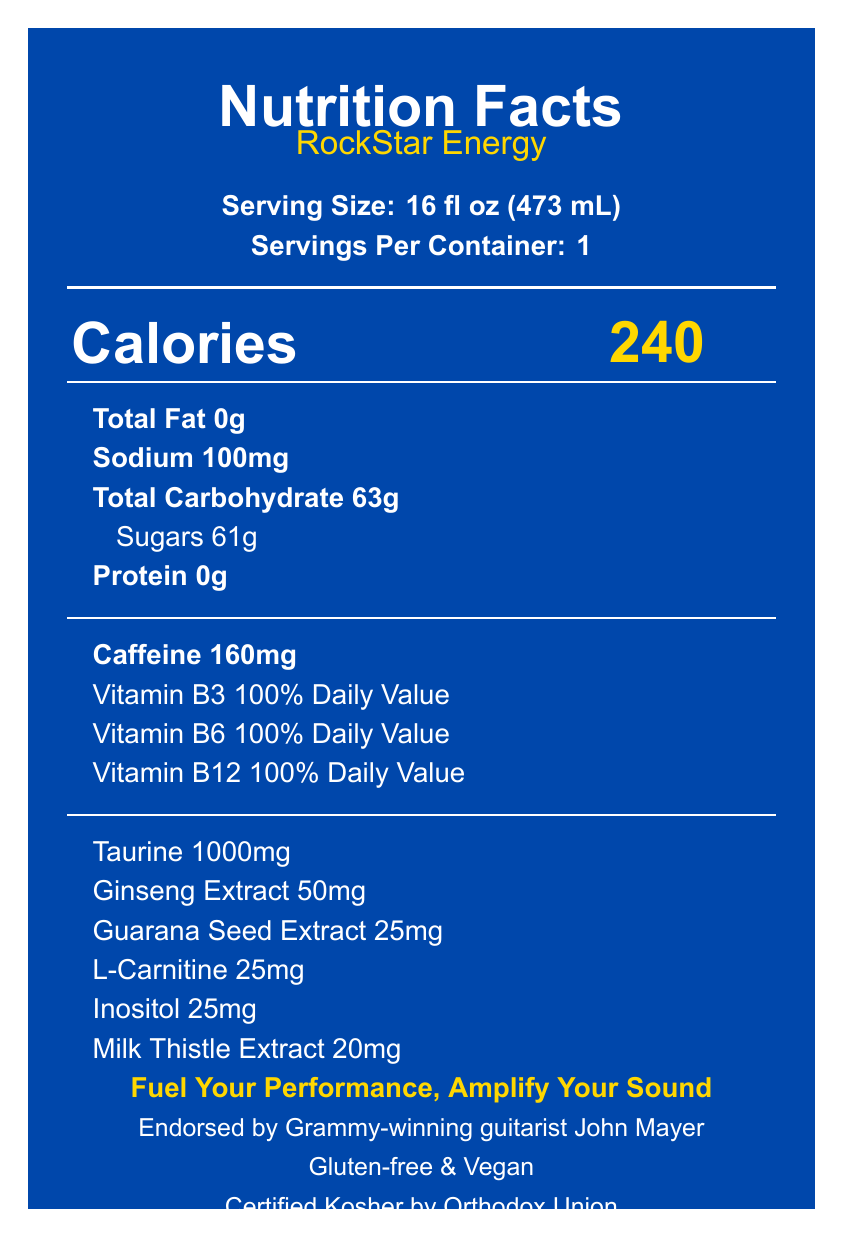what is the serving size for RockStar Energy? The serving size is clearly listed as 16 fl oz (473 mL) in the serving information section.
Answer: 16 fl oz (473 mL) how many calories are in one serving of RockStar Energy? The number of calories is prominently displayed in a large font next to the "Calories" label in the document.
Answer: 240 how much sodium is in RockStar Energy? The amount of sodium is listed in the nutrient information section as 100mg.
Answer: 100mg how much sugar does RockStar Energy contain? The sugars content is specifically listed as 61g underneath Total Carbohydrate in the nutrient information section.
Answer: 61g how much caffeine is in RockStar Energy? The amount of caffeine is provided in the additional nutrients section as 160mg.
Answer: 160mg what vitamins are included in RockStar Energy? The additional nutrients section lists Vitamin B3, Vitamin B6, and Vitamin B12 with a 100% daily value each.
Answer: Vitamin B3, Vitamin B6, and Vitamin B12 what is the tagline for RockStar Energy? The tagline is highlighted in the marketing tagline section in a standout color.
Answer: Fuel Your Performance, Amplify Your Sound is RockStar Energy vegan? The dietary information section clearly states that the product is Vegan.
Answer: Yes is RockStar Energy certified kosher? The document states that the product is Certified Kosher by Orthodox Union, in the dietary info section at the bottom.
Answer: Yes which musician endorses RockStar Energy? A. John Mayer B. Eric Clapton C. Santana D. Stevie Ray Vaughan The document notes the endorsement by Grammy-winning guitarist John Mayer in the musician endorsement section.
Answer: A. John Mayer what are the flavors of RockStar Energy? A. Apple and Citrus B. Berry and Tropical C. Citrus and Berry D. Tropical and Berry The flavors listed in the document are Citrus and Berry Blend.
Answer: C. Citrus and Berry which of the following information is NOT provided on this Nutrition Facts Label? A. Protein content B. Serving size C. Company history D. Sugar content The document does not provide any historical information about the company; it focuses on nutritional and promotional details.
Answer: C. Company history is RockStar Energy safe for children or pregnant women? The warning section advises that the product is not recommended for children, pregnant women, or individuals sensitive to caffeine.
Answer: No summarize the main idea of the RockStar Energy Nutrition Facts Label. The label provides nutritional details, serving information, additional ingredients, dietary notes, a promotional message, and endorsements, all presented with clear and standout graphical and textual elements.
Answer: The RockStar Energy Nutrition Facts Label details serving size, nutrient content, key ingredients like caffeine and vitamins, along with additional elements such as dietary information, an endorsement by John Mayer, and a tagline promoting performance. what is the purpose of the milk thistle extract listed in RockStar Energy? The document provides the amount of milk thistle extract but does not give any information regarding its specific purpose or benefits in the energy drink.
Answer: Cannot be determined 